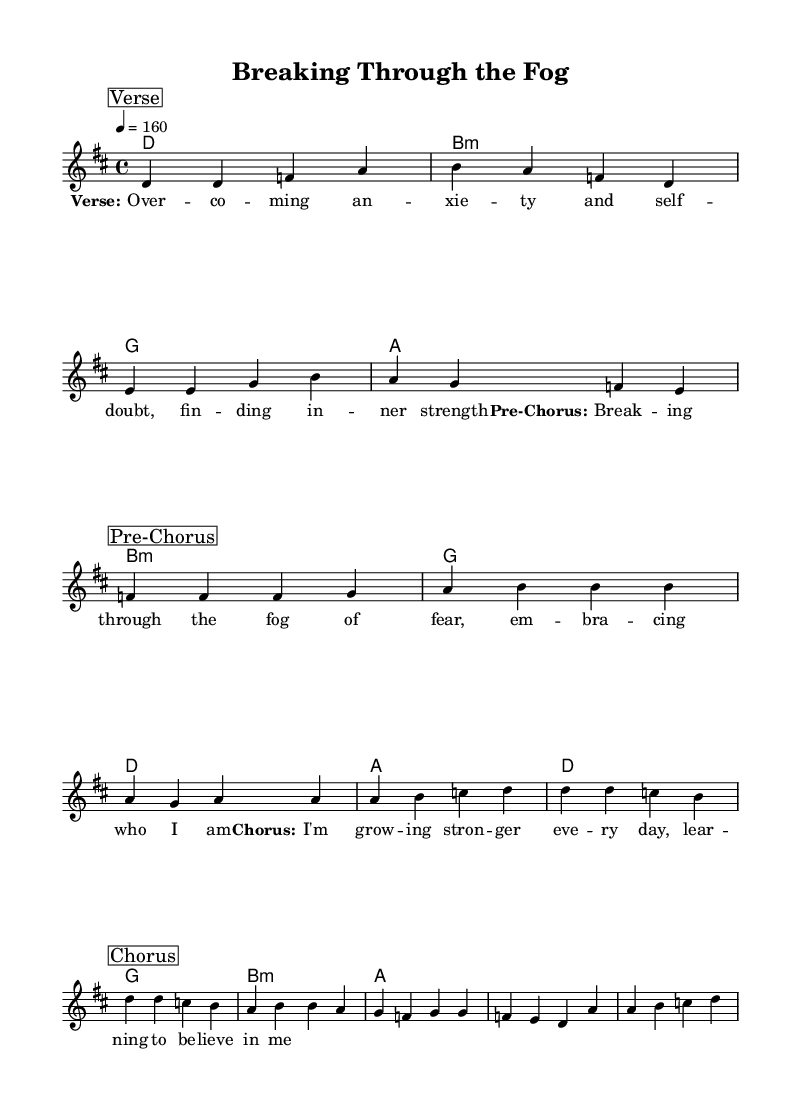What is the key signature of this music? The key signature shows two sharps, indicating that it is in D major.
Answer: D major What is the time signature of the piece? The time signature is indicated at the beginning of the score as 4/4, which means there are four beats in each measure and the quarter note gets one beat.
Answer: 4/4 What is the tempo marking for the piece? The tempo marking indicates that the piece should be played at a speed of 160 beats per minute.
Answer: 160 What section follows the verse? Upon examining the structure of the piece, the section that follows the verse is the pre-chorus, as indicated by the break and marker in the score.
Answer: Pre-Chorus How many measures are in the chorus? Counting the notes in the chorus section, there are four measures present, as indicated by the grouping of the notes in this section.
Answer: Four What is the emotional focus of the lyrics? By analyzing the lyrics provided in the music sheet, the emotional focus centers around themes of personal growth and self-acceptance related to mental health struggles.
Answer: Personal growth Which chord is played in the first measure? The harmonies show that the chord played in the first measure is a D major chord, as indicated by the chord symbols below the staff.
Answer: D major 